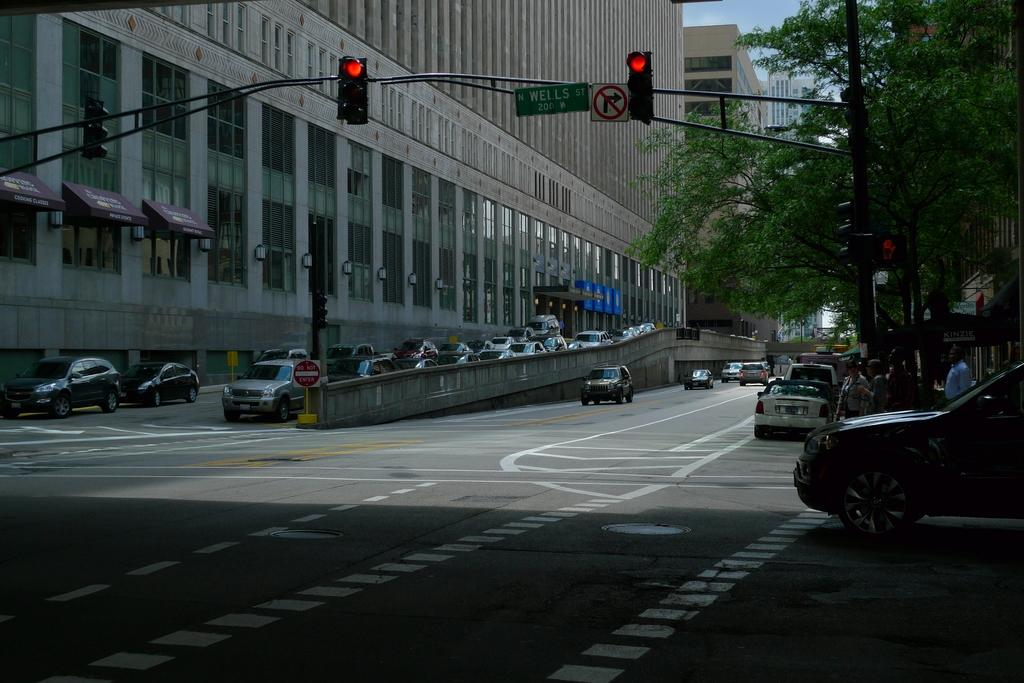<image>
Share a concise interpretation of the image provided. A red traffic light is next to a green street sign that says Wells St. 